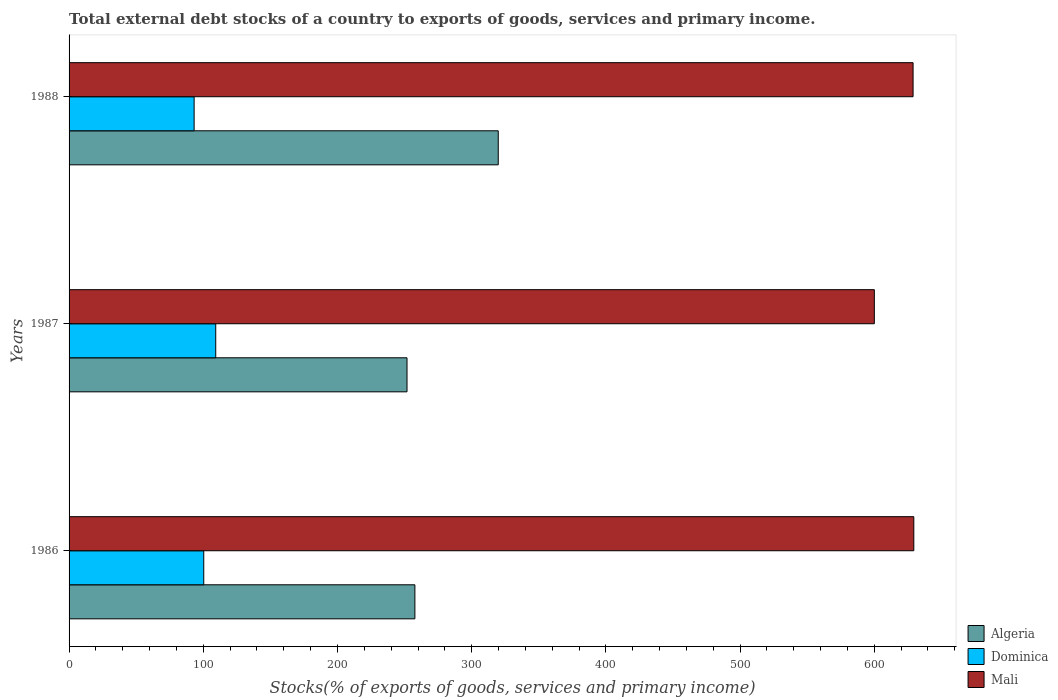How many different coloured bars are there?
Offer a terse response. 3. How many groups of bars are there?
Ensure brevity in your answer.  3. Are the number of bars per tick equal to the number of legend labels?
Keep it short and to the point. Yes. Are the number of bars on each tick of the Y-axis equal?
Give a very brief answer. Yes. How many bars are there on the 2nd tick from the top?
Offer a terse response. 3. In how many cases, is the number of bars for a given year not equal to the number of legend labels?
Your response must be concise. 0. What is the total debt stocks in Algeria in 1988?
Your response must be concise. 319.8. Across all years, what is the maximum total debt stocks in Algeria?
Provide a short and direct response. 319.8. Across all years, what is the minimum total debt stocks in Dominica?
Give a very brief answer. 93.19. What is the total total debt stocks in Mali in the graph?
Provide a succinct answer. 1858.41. What is the difference between the total debt stocks in Algeria in 1986 and that in 1988?
Provide a succinct answer. -62.12. What is the difference between the total debt stocks in Mali in 1987 and the total debt stocks in Algeria in 1988?
Offer a terse response. 280.24. What is the average total debt stocks in Mali per year?
Provide a succinct answer. 619.47. In the year 1987, what is the difference between the total debt stocks in Dominica and total debt stocks in Mali?
Make the answer very short. -490.76. What is the ratio of the total debt stocks in Algeria in 1987 to that in 1988?
Provide a short and direct response. 0.79. Is the total debt stocks in Algeria in 1986 less than that in 1988?
Provide a succinct answer. Yes. Is the difference between the total debt stocks in Dominica in 1986 and 1988 greater than the difference between the total debt stocks in Mali in 1986 and 1988?
Offer a terse response. Yes. What is the difference between the highest and the second highest total debt stocks in Algeria?
Provide a short and direct response. 62.12. What is the difference between the highest and the lowest total debt stocks in Dominica?
Provide a succinct answer. 16.1. Is the sum of the total debt stocks in Dominica in 1986 and 1988 greater than the maximum total debt stocks in Algeria across all years?
Make the answer very short. No. What does the 1st bar from the top in 1987 represents?
Ensure brevity in your answer.  Mali. What does the 3rd bar from the bottom in 1987 represents?
Your answer should be compact. Mali. Are all the bars in the graph horizontal?
Provide a succinct answer. Yes. How many years are there in the graph?
Your answer should be very brief. 3. What is the difference between two consecutive major ticks on the X-axis?
Your response must be concise. 100. How are the legend labels stacked?
Provide a succinct answer. Vertical. What is the title of the graph?
Keep it short and to the point. Total external debt stocks of a country to exports of goods, services and primary income. Does "Micronesia" appear as one of the legend labels in the graph?
Offer a very short reply. No. What is the label or title of the X-axis?
Make the answer very short. Stocks(% of exports of goods, services and primary income). What is the label or title of the Y-axis?
Provide a short and direct response. Years. What is the Stocks(% of exports of goods, services and primary income) of Algeria in 1986?
Give a very brief answer. 257.68. What is the Stocks(% of exports of goods, services and primary income) of Dominica in 1986?
Provide a succinct answer. 100.35. What is the Stocks(% of exports of goods, services and primary income) in Mali in 1986?
Your answer should be very brief. 629.46. What is the Stocks(% of exports of goods, services and primary income) in Algeria in 1987?
Give a very brief answer. 251.82. What is the Stocks(% of exports of goods, services and primary income) of Dominica in 1987?
Offer a very short reply. 109.28. What is the Stocks(% of exports of goods, services and primary income) in Mali in 1987?
Provide a succinct answer. 600.04. What is the Stocks(% of exports of goods, services and primary income) in Algeria in 1988?
Keep it short and to the point. 319.8. What is the Stocks(% of exports of goods, services and primary income) of Dominica in 1988?
Offer a very short reply. 93.19. What is the Stocks(% of exports of goods, services and primary income) in Mali in 1988?
Your answer should be very brief. 628.91. Across all years, what is the maximum Stocks(% of exports of goods, services and primary income) in Algeria?
Offer a very short reply. 319.8. Across all years, what is the maximum Stocks(% of exports of goods, services and primary income) of Dominica?
Your response must be concise. 109.28. Across all years, what is the maximum Stocks(% of exports of goods, services and primary income) in Mali?
Provide a succinct answer. 629.46. Across all years, what is the minimum Stocks(% of exports of goods, services and primary income) in Algeria?
Offer a very short reply. 251.82. Across all years, what is the minimum Stocks(% of exports of goods, services and primary income) in Dominica?
Make the answer very short. 93.19. Across all years, what is the minimum Stocks(% of exports of goods, services and primary income) of Mali?
Offer a terse response. 600.04. What is the total Stocks(% of exports of goods, services and primary income) in Algeria in the graph?
Ensure brevity in your answer.  829.3. What is the total Stocks(% of exports of goods, services and primary income) in Dominica in the graph?
Make the answer very short. 302.82. What is the total Stocks(% of exports of goods, services and primary income) in Mali in the graph?
Give a very brief answer. 1858.41. What is the difference between the Stocks(% of exports of goods, services and primary income) of Algeria in 1986 and that in 1987?
Make the answer very short. 5.87. What is the difference between the Stocks(% of exports of goods, services and primary income) in Dominica in 1986 and that in 1987?
Give a very brief answer. -8.93. What is the difference between the Stocks(% of exports of goods, services and primary income) of Mali in 1986 and that in 1987?
Give a very brief answer. 29.41. What is the difference between the Stocks(% of exports of goods, services and primary income) in Algeria in 1986 and that in 1988?
Your response must be concise. -62.12. What is the difference between the Stocks(% of exports of goods, services and primary income) of Dominica in 1986 and that in 1988?
Offer a terse response. 7.17. What is the difference between the Stocks(% of exports of goods, services and primary income) in Mali in 1986 and that in 1988?
Ensure brevity in your answer.  0.55. What is the difference between the Stocks(% of exports of goods, services and primary income) in Algeria in 1987 and that in 1988?
Your answer should be compact. -67.98. What is the difference between the Stocks(% of exports of goods, services and primary income) of Dominica in 1987 and that in 1988?
Provide a succinct answer. 16.1. What is the difference between the Stocks(% of exports of goods, services and primary income) in Mali in 1987 and that in 1988?
Make the answer very short. -28.87. What is the difference between the Stocks(% of exports of goods, services and primary income) in Algeria in 1986 and the Stocks(% of exports of goods, services and primary income) in Dominica in 1987?
Provide a short and direct response. 148.4. What is the difference between the Stocks(% of exports of goods, services and primary income) in Algeria in 1986 and the Stocks(% of exports of goods, services and primary income) in Mali in 1987?
Make the answer very short. -342.36. What is the difference between the Stocks(% of exports of goods, services and primary income) of Dominica in 1986 and the Stocks(% of exports of goods, services and primary income) of Mali in 1987?
Your response must be concise. -499.69. What is the difference between the Stocks(% of exports of goods, services and primary income) in Algeria in 1986 and the Stocks(% of exports of goods, services and primary income) in Dominica in 1988?
Provide a short and direct response. 164.5. What is the difference between the Stocks(% of exports of goods, services and primary income) of Algeria in 1986 and the Stocks(% of exports of goods, services and primary income) of Mali in 1988?
Offer a very short reply. -371.23. What is the difference between the Stocks(% of exports of goods, services and primary income) of Dominica in 1986 and the Stocks(% of exports of goods, services and primary income) of Mali in 1988?
Keep it short and to the point. -528.56. What is the difference between the Stocks(% of exports of goods, services and primary income) of Algeria in 1987 and the Stocks(% of exports of goods, services and primary income) of Dominica in 1988?
Provide a short and direct response. 158.63. What is the difference between the Stocks(% of exports of goods, services and primary income) of Algeria in 1987 and the Stocks(% of exports of goods, services and primary income) of Mali in 1988?
Make the answer very short. -377.1. What is the difference between the Stocks(% of exports of goods, services and primary income) in Dominica in 1987 and the Stocks(% of exports of goods, services and primary income) in Mali in 1988?
Keep it short and to the point. -519.63. What is the average Stocks(% of exports of goods, services and primary income) of Algeria per year?
Keep it short and to the point. 276.43. What is the average Stocks(% of exports of goods, services and primary income) in Dominica per year?
Ensure brevity in your answer.  100.94. What is the average Stocks(% of exports of goods, services and primary income) in Mali per year?
Ensure brevity in your answer.  619.47. In the year 1986, what is the difference between the Stocks(% of exports of goods, services and primary income) in Algeria and Stocks(% of exports of goods, services and primary income) in Dominica?
Offer a terse response. 157.33. In the year 1986, what is the difference between the Stocks(% of exports of goods, services and primary income) in Algeria and Stocks(% of exports of goods, services and primary income) in Mali?
Keep it short and to the point. -371.77. In the year 1986, what is the difference between the Stocks(% of exports of goods, services and primary income) in Dominica and Stocks(% of exports of goods, services and primary income) in Mali?
Ensure brevity in your answer.  -529.11. In the year 1987, what is the difference between the Stocks(% of exports of goods, services and primary income) in Algeria and Stocks(% of exports of goods, services and primary income) in Dominica?
Make the answer very short. 142.53. In the year 1987, what is the difference between the Stocks(% of exports of goods, services and primary income) of Algeria and Stocks(% of exports of goods, services and primary income) of Mali?
Keep it short and to the point. -348.23. In the year 1987, what is the difference between the Stocks(% of exports of goods, services and primary income) of Dominica and Stocks(% of exports of goods, services and primary income) of Mali?
Offer a very short reply. -490.76. In the year 1988, what is the difference between the Stocks(% of exports of goods, services and primary income) in Algeria and Stocks(% of exports of goods, services and primary income) in Dominica?
Provide a short and direct response. 226.61. In the year 1988, what is the difference between the Stocks(% of exports of goods, services and primary income) of Algeria and Stocks(% of exports of goods, services and primary income) of Mali?
Provide a succinct answer. -309.11. In the year 1988, what is the difference between the Stocks(% of exports of goods, services and primary income) in Dominica and Stocks(% of exports of goods, services and primary income) in Mali?
Your answer should be very brief. -535.73. What is the ratio of the Stocks(% of exports of goods, services and primary income) of Algeria in 1986 to that in 1987?
Provide a short and direct response. 1.02. What is the ratio of the Stocks(% of exports of goods, services and primary income) in Dominica in 1986 to that in 1987?
Offer a very short reply. 0.92. What is the ratio of the Stocks(% of exports of goods, services and primary income) in Mali in 1986 to that in 1987?
Your answer should be compact. 1.05. What is the ratio of the Stocks(% of exports of goods, services and primary income) in Algeria in 1986 to that in 1988?
Ensure brevity in your answer.  0.81. What is the ratio of the Stocks(% of exports of goods, services and primary income) in Mali in 1986 to that in 1988?
Give a very brief answer. 1. What is the ratio of the Stocks(% of exports of goods, services and primary income) in Algeria in 1987 to that in 1988?
Provide a short and direct response. 0.79. What is the ratio of the Stocks(% of exports of goods, services and primary income) of Dominica in 1987 to that in 1988?
Make the answer very short. 1.17. What is the ratio of the Stocks(% of exports of goods, services and primary income) of Mali in 1987 to that in 1988?
Keep it short and to the point. 0.95. What is the difference between the highest and the second highest Stocks(% of exports of goods, services and primary income) in Algeria?
Your response must be concise. 62.12. What is the difference between the highest and the second highest Stocks(% of exports of goods, services and primary income) in Dominica?
Give a very brief answer. 8.93. What is the difference between the highest and the second highest Stocks(% of exports of goods, services and primary income) of Mali?
Offer a very short reply. 0.55. What is the difference between the highest and the lowest Stocks(% of exports of goods, services and primary income) of Algeria?
Your answer should be very brief. 67.98. What is the difference between the highest and the lowest Stocks(% of exports of goods, services and primary income) of Dominica?
Keep it short and to the point. 16.1. What is the difference between the highest and the lowest Stocks(% of exports of goods, services and primary income) of Mali?
Ensure brevity in your answer.  29.41. 